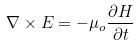Convert formula to latex. <formula><loc_0><loc_0><loc_500><loc_500>\nabla \times E = - \mu _ { o } \frac { \partial H } { \partial t }</formula> 